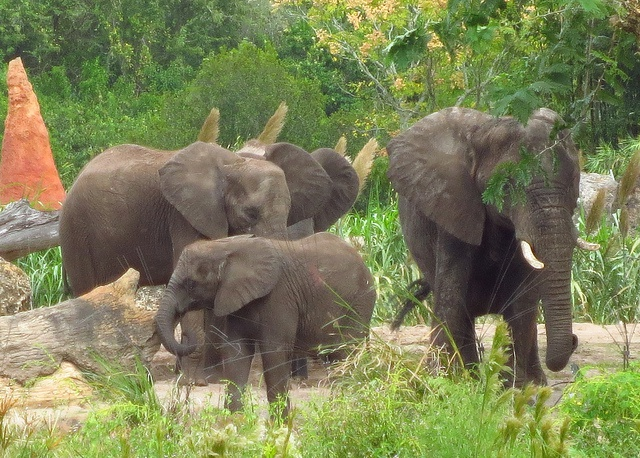Describe the objects in this image and their specific colors. I can see elephant in green, gray, black, and darkgreen tones, elephant in green, gray, and black tones, and elephant in green and gray tones in this image. 